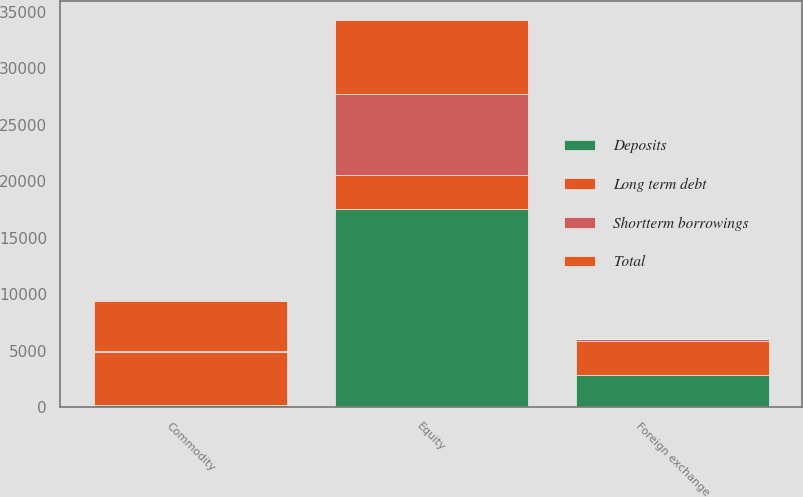Convert chart. <chart><loc_0><loc_0><loc_500><loc_500><stacked_bar_chart><ecel><fcel>Foreign exchange<fcel>Equity<fcel>Commodity<nl><fcel>Deposits<fcel>2841<fcel>17581<fcel>230<nl><fcel>Shortterm borrowings<fcel>147<fcel>7106<fcel>15<nl><fcel>Total<fcel>38<fcel>6548<fcel>4468<nl><fcel>Long term debt<fcel>3026<fcel>3026<fcel>4713<nl></chart> 